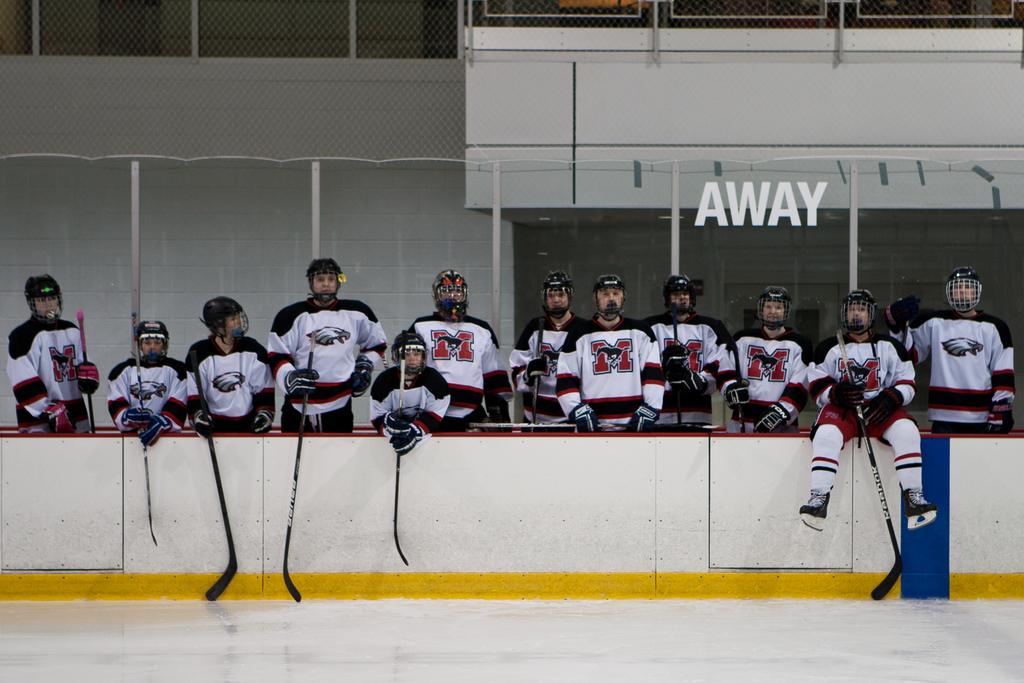What is show on?
Keep it short and to the point. Away. 